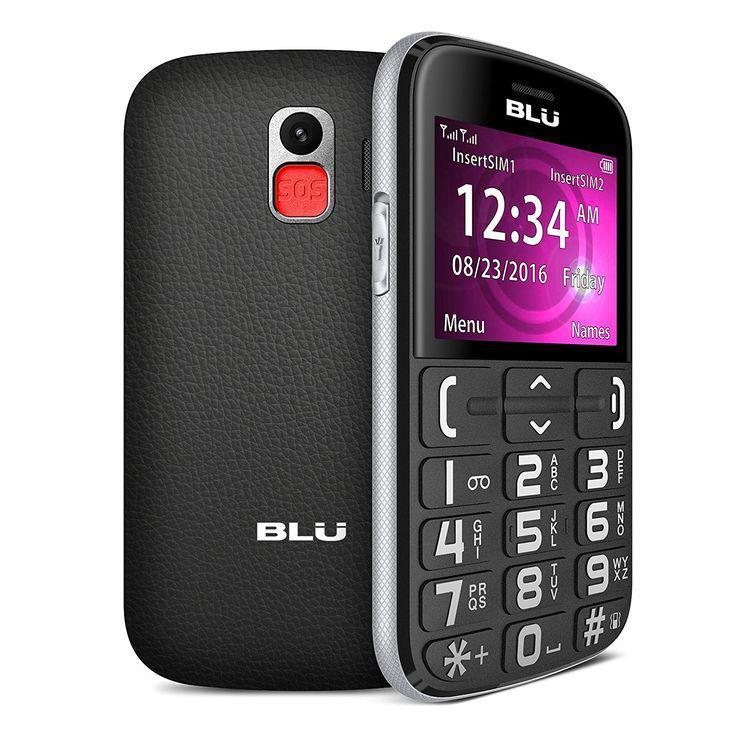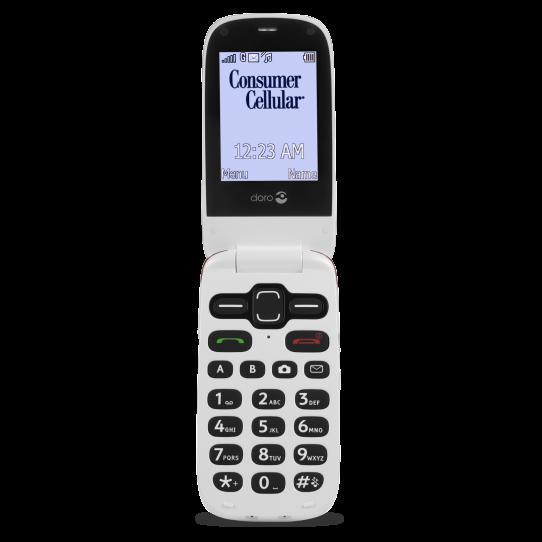The first image is the image on the left, the second image is the image on the right. Considering the images on both sides, is "Left and right images each show an open white flip phone with black buttons, rounded corners, and something displayed on the screen." valid? Answer yes or no. No. 